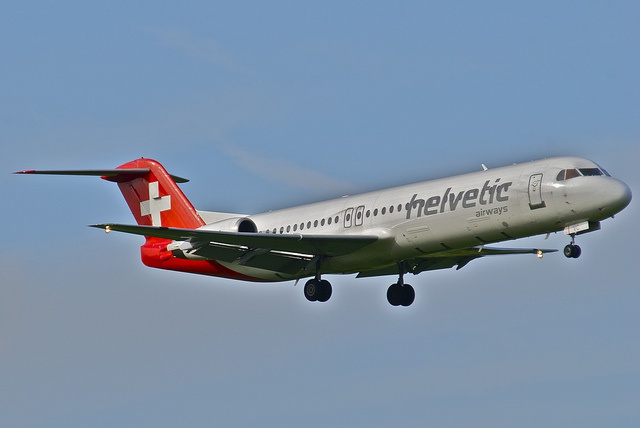Describe the objects in this image and their specific colors. I can see a airplane in darkgray, black, lightgray, and gray tones in this image. 